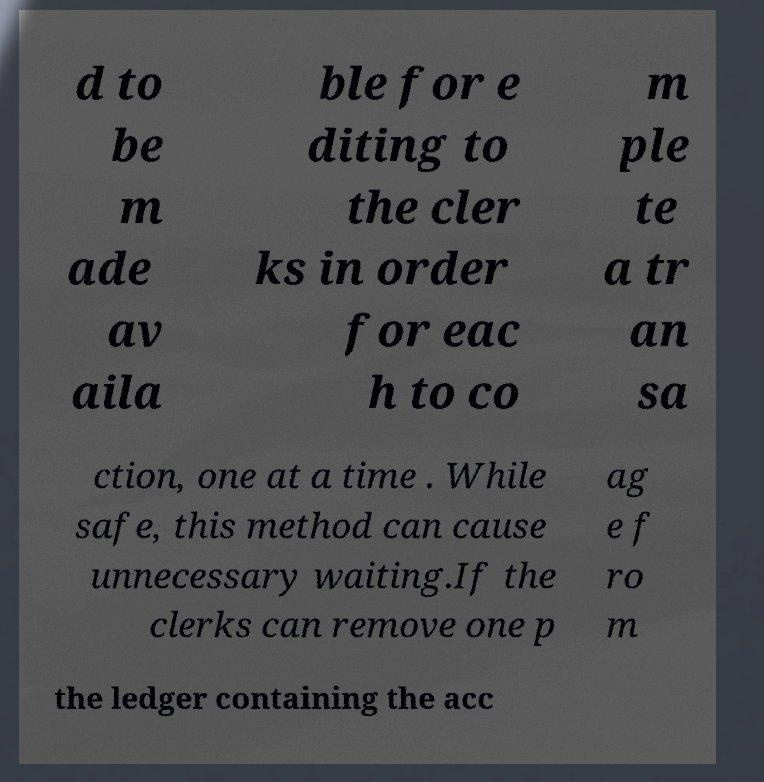I need the written content from this picture converted into text. Can you do that? d to be m ade av aila ble for e diting to the cler ks in order for eac h to co m ple te a tr an sa ction, one at a time . While safe, this method can cause unnecessary waiting.If the clerks can remove one p ag e f ro m the ledger containing the acc 